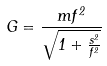<formula> <loc_0><loc_0><loc_500><loc_500>G = \frac { m f ^ { 2 } } { \sqrt { 1 + \frac { s ^ { 2 } } { f ^ { 2 } } } }</formula> 